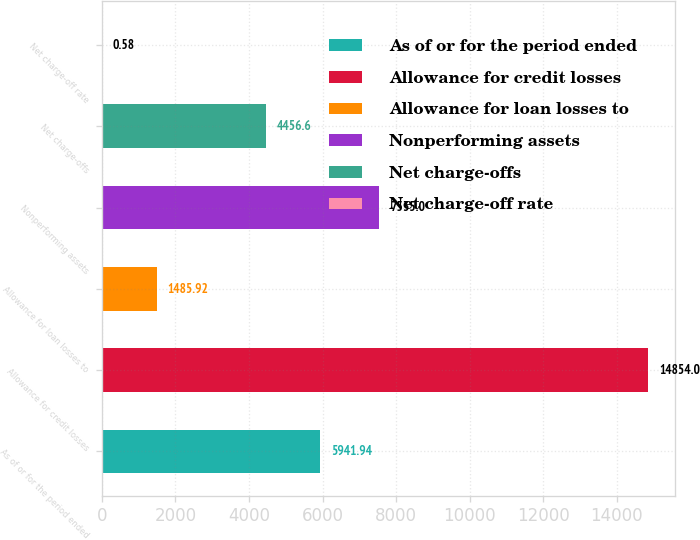Convert chart. <chart><loc_0><loc_0><loc_500><loc_500><bar_chart><fcel>As of or for the period ended<fcel>Allowance for credit losses<fcel>Allowance for loan losses to<fcel>Nonperforming assets<fcel>Net charge-offs<fcel>Net charge-off rate<nl><fcel>5941.94<fcel>14854<fcel>1485.92<fcel>7535<fcel>4456.6<fcel>0.58<nl></chart> 